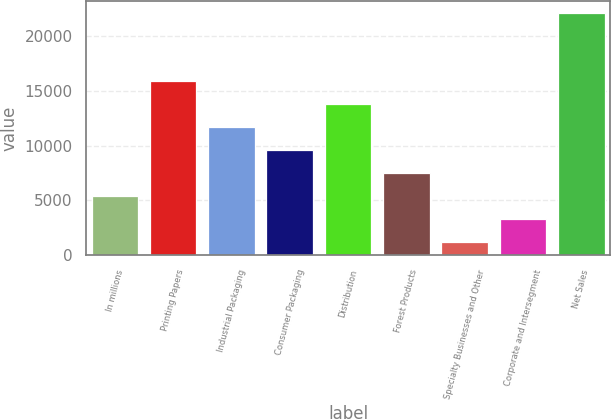Convert chart to OTSL. <chart><loc_0><loc_0><loc_500><loc_500><bar_chart><fcel>In millions<fcel>Printing Papers<fcel>Industrial Packaging<fcel>Consumer Packaging<fcel>Distribution<fcel>Forest Products<fcel>Specialty Businesses and Other<fcel>Corporate and Intersegment<fcel>Net Sales<nl><fcel>5415.6<fcel>15867.1<fcel>11686.5<fcel>9596.2<fcel>13776.8<fcel>7505.9<fcel>1235<fcel>3325.3<fcel>22138<nl></chart> 